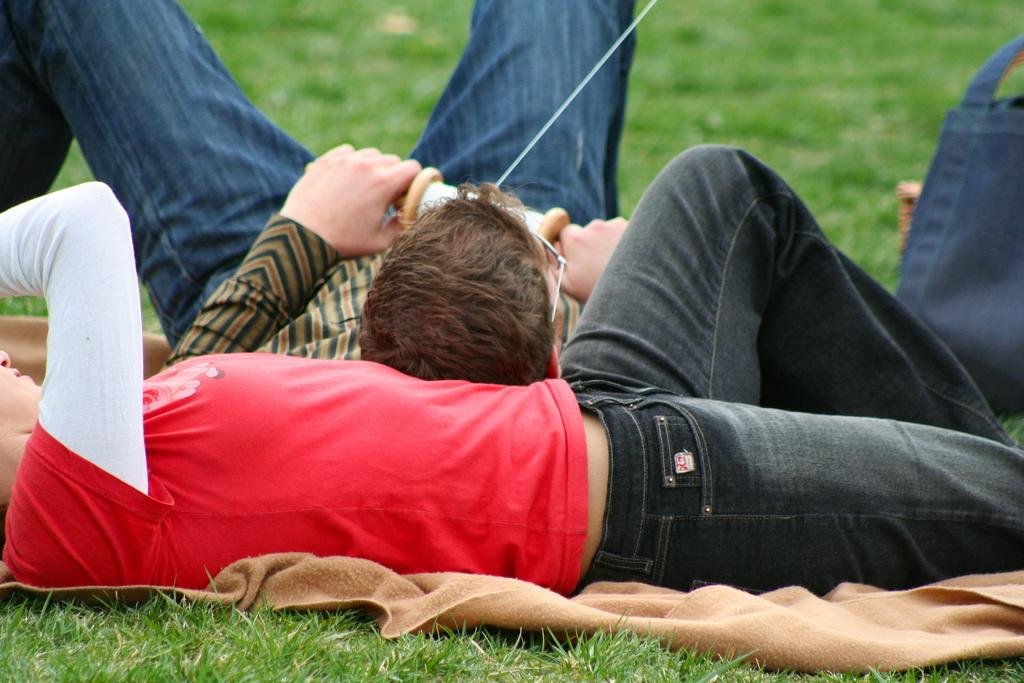How many people are in the image? There are two people in the image. What are the people doing in the image? The people are laying on the grass. What is beneath the people? There is a cloth beneath the people. What can be seen on the right side of the image? There is a bag on the right side of the image. What type of pump is visible in the image? There is no pump present in the image. Is there a fireman in the image? No, there are no firemen in the image. 